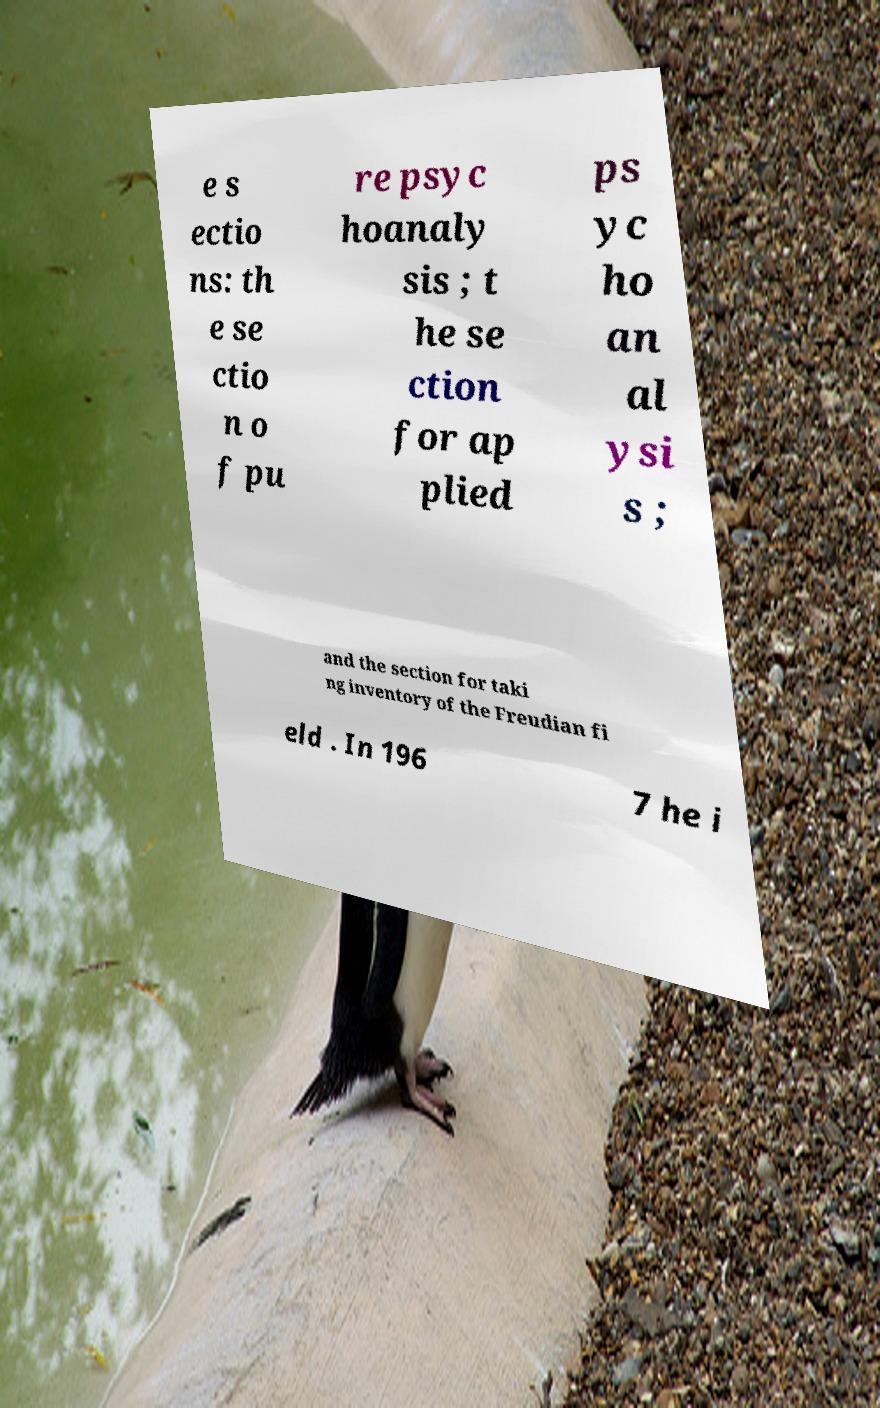For documentation purposes, I need the text within this image transcribed. Could you provide that? e s ectio ns: th e se ctio n o f pu re psyc hoanaly sis ; t he se ction for ap plied ps yc ho an al ysi s ; and the section for taki ng inventory of the Freudian fi eld . In 196 7 he i 